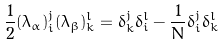Convert formula to latex. <formula><loc_0><loc_0><loc_500><loc_500>\frac { 1 } { 2 } ( \lambda _ { \alpha } ) ^ { j } _ { i } ( \lambda _ { \beta } ) ^ { l } _ { k } = \delta ^ { j } _ { k } \delta ^ { l } _ { i } - \frac { 1 } { N } \delta ^ { j } _ { i } \delta ^ { l } _ { k }</formula> 